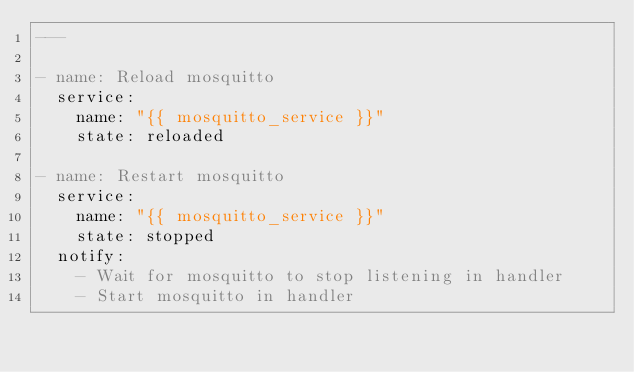Convert code to text. <code><loc_0><loc_0><loc_500><loc_500><_YAML_>---

- name: Reload mosquitto
  service:
    name: "{{ mosquitto_service }}"
    state: reloaded

- name: Restart mosquitto
  service:
    name: "{{ mosquitto_service }}"
    state: stopped
  notify:
    - Wait for mosquitto to stop listening in handler
    - Start mosquitto in handler</code> 